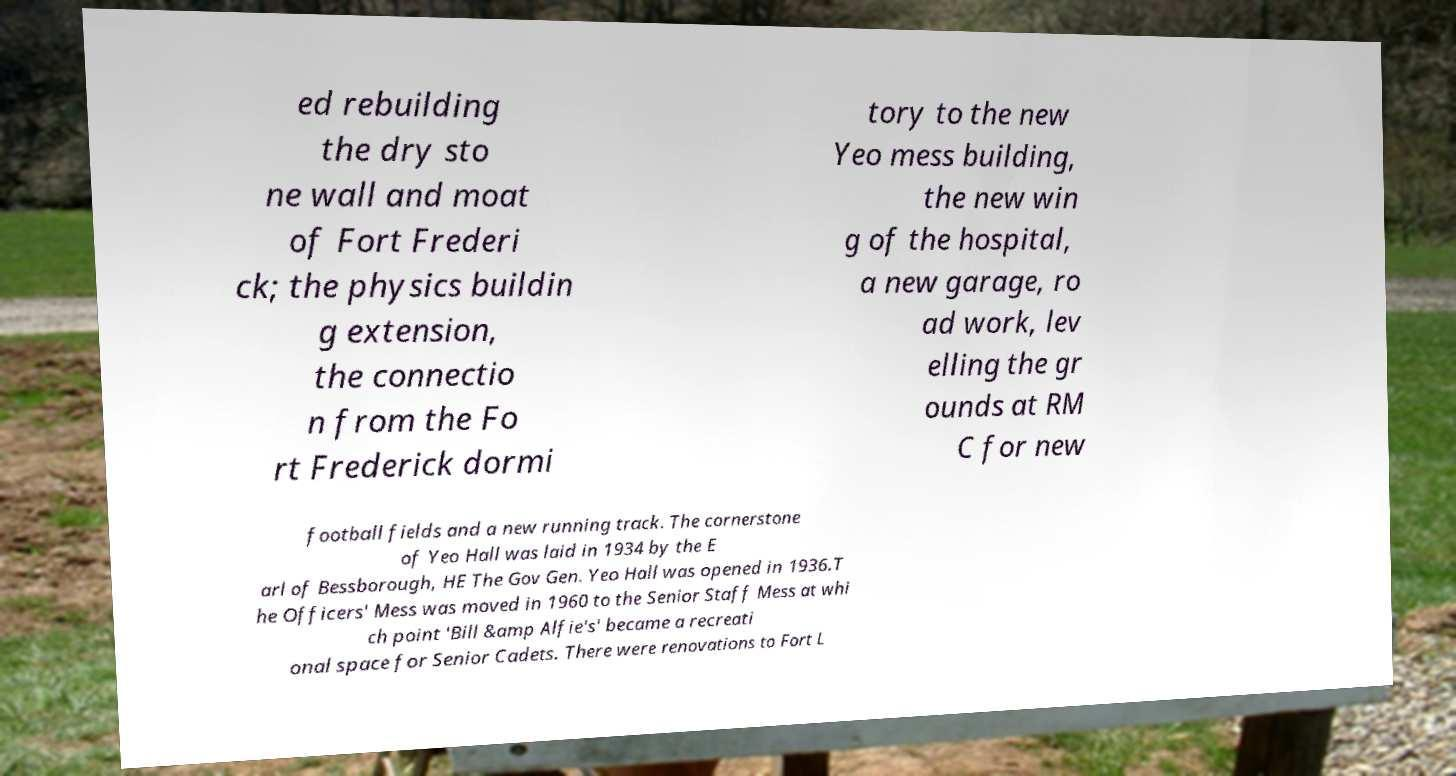Can you accurately transcribe the text from the provided image for me? ed rebuilding the dry sto ne wall and moat of Fort Frederi ck; the physics buildin g extension, the connectio n from the Fo rt Frederick dormi tory to the new Yeo mess building, the new win g of the hospital, a new garage, ro ad work, lev elling the gr ounds at RM C for new football fields and a new running track. The cornerstone of Yeo Hall was laid in 1934 by the E arl of Bessborough, HE The Gov Gen. Yeo Hall was opened in 1936.T he Officers' Mess was moved in 1960 to the Senior Staff Mess at whi ch point 'Bill &amp Alfie's' became a recreati onal space for Senior Cadets. There were renovations to Fort L 